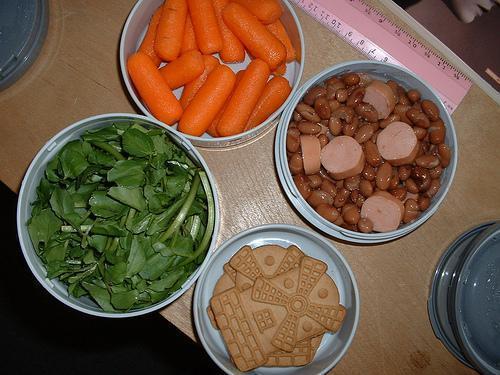How many containers are there?
Give a very brief answer. 4. How many plates only contain vegetables?
Give a very brief answer. 2. How many bowls are there?
Give a very brief answer. 5. How many carrots are there?
Give a very brief answer. 2. How many boats can be seen?
Give a very brief answer. 0. 